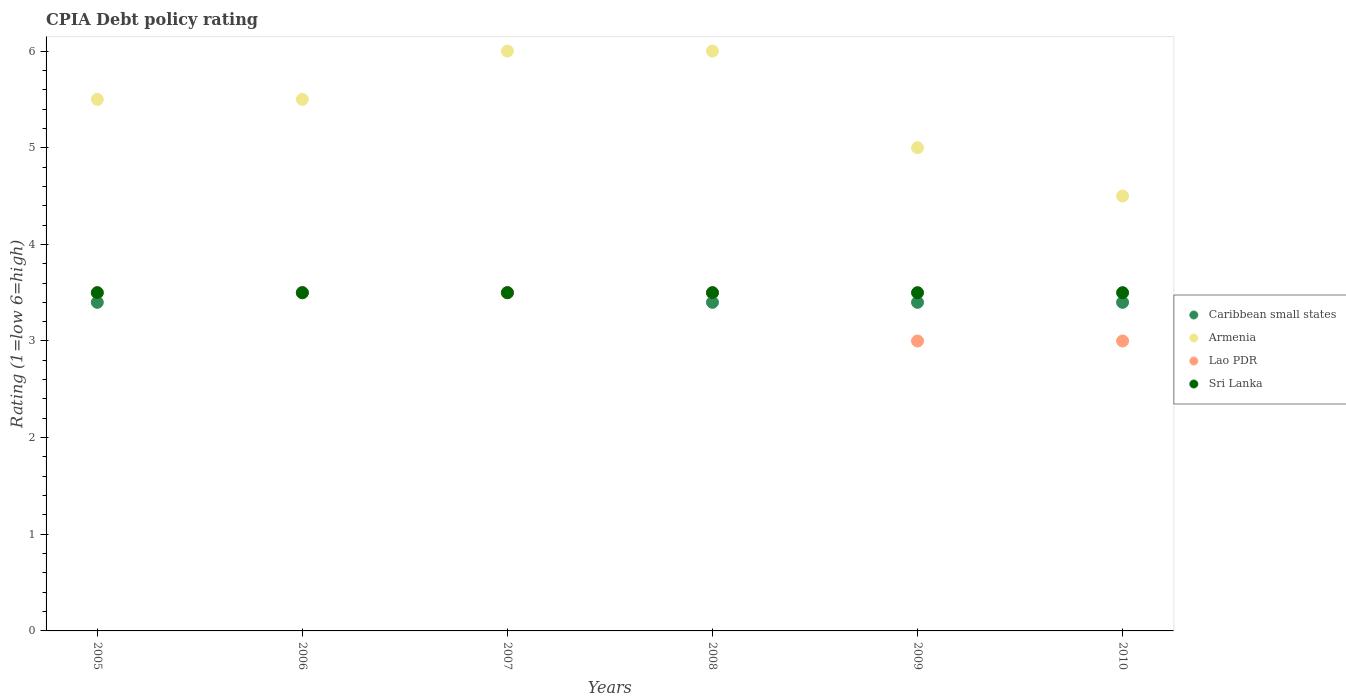Is the number of dotlines equal to the number of legend labels?
Your response must be concise. Yes. Across all years, what is the maximum CPIA rating in Caribbean small states?
Offer a terse response. 3.5. Across all years, what is the minimum CPIA rating in Armenia?
Offer a very short reply. 4.5. What is the difference between the CPIA rating in Sri Lanka in 2009 and that in 2010?
Give a very brief answer. 0. What is the difference between the CPIA rating in Lao PDR in 2010 and the CPIA rating in Armenia in 2007?
Give a very brief answer. -3. What is the average CPIA rating in Lao PDR per year?
Your answer should be very brief. 3.33. In the year 2008, what is the difference between the CPIA rating in Caribbean small states and CPIA rating in Lao PDR?
Make the answer very short. -0.1. In how many years, is the CPIA rating in Caribbean small states greater than 2.6?
Offer a terse response. 6. What is the ratio of the CPIA rating in Caribbean small states in 2007 to that in 2008?
Keep it short and to the point. 1.03. Is it the case that in every year, the sum of the CPIA rating in Armenia and CPIA rating in Lao PDR  is greater than the CPIA rating in Sri Lanka?
Your answer should be very brief. Yes. Does the CPIA rating in Armenia monotonically increase over the years?
Ensure brevity in your answer.  No. Is the CPIA rating in Caribbean small states strictly greater than the CPIA rating in Armenia over the years?
Keep it short and to the point. No. How many dotlines are there?
Keep it short and to the point. 4. Are the values on the major ticks of Y-axis written in scientific E-notation?
Provide a short and direct response. No. Does the graph contain any zero values?
Your answer should be very brief. No. How many legend labels are there?
Keep it short and to the point. 4. What is the title of the graph?
Give a very brief answer. CPIA Debt policy rating. Does "New Caledonia" appear as one of the legend labels in the graph?
Offer a terse response. No. What is the label or title of the X-axis?
Your response must be concise. Years. What is the Rating (1=low 6=high) in Caribbean small states in 2005?
Give a very brief answer. 3.4. What is the Rating (1=low 6=high) in Armenia in 2005?
Offer a terse response. 5.5. What is the Rating (1=low 6=high) of Sri Lanka in 2005?
Offer a very short reply. 3.5. What is the Rating (1=low 6=high) in Lao PDR in 2006?
Provide a short and direct response. 3.5. What is the Rating (1=low 6=high) in Caribbean small states in 2007?
Your response must be concise. 3.5. What is the Rating (1=low 6=high) of Armenia in 2007?
Offer a very short reply. 6. What is the Rating (1=low 6=high) in Lao PDR in 2007?
Make the answer very short. 3.5. What is the Rating (1=low 6=high) in Armenia in 2008?
Make the answer very short. 6. What is the Rating (1=low 6=high) in Sri Lanka in 2008?
Your answer should be compact. 3.5. What is the Rating (1=low 6=high) in Caribbean small states in 2009?
Keep it short and to the point. 3.4. What is the Rating (1=low 6=high) of Armenia in 2009?
Your answer should be compact. 5. What is the Rating (1=low 6=high) of Sri Lanka in 2009?
Provide a short and direct response. 3.5. What is the Rating (1=low 6=high) in Armenia in 2010?
Keep it short and to the point. 4.5. What is the Rating (1=low 6=high) in Lao PDR in 2010?
Ensure brevity in your answer.  3. Across all years, what is the maximum Rating (1=low 6=high) in Sri Lanka?
Offer a very short reply. 3.5. Across all years, what is the minimum Rating (1=low 6=high) in Armenia?
Give a very brief answer. 4.5. What is the total Rating (1=low 6=high) of Caribbean small states in the graph?
Provide a short and direct response. 20.6. What is the total Rating (1=low 6=high) in Armenia in the graph?
Your answer should be very brief. 32.5. What is the difference between the Rating (1=low 6=high) in Lao PDR in 2005 and that in 2006?
Offer a very short reply. 0. What is the difference between the Rating (1=low 6=high) of Sri Lanka in 2005 and that in 2006?
Keep it short and to the point. 0. What is the difference between the Rating (1=low 6=high) of Caribbean small states in 2005 and that in 2007?
Offer a very short reply. -0.1. What is the difference between the Rating (1=low 6=high) of Armenia in 2005 and that in 2007?
Provide a short and direct response. -0.5. What is the difference between the Rating (1=low 6=high) of Lao PDR in 2005 and that in 2007?
Your answer should be very brief. 0. What is the difference between the Rating (1=low 6=high) of Sri Lanka in 2005 and that in 2007?
Provide a succinct answer. 0. What is the difference between the Rating (1=low 6=high) of Armenia in 2005 and that in 2008?
Your answer should be compact. -0.5. What is the difference between the Rating (1=low 6=high) of Lao PDR in 2005 and that in 2008?
Your answer should be very brief. 0. What is the difference between the Rating (1=low 6=high) in Sri Lanka in 2005 and that in 2008?
Ensure brevity in your answer.  0. What is the difference between the Rating (1=low 6=high) in Caribbean small states in 2005 and that in 2009?
Your answer should be compact. 0. What is the difference between the Rating (1=low 6=high) in Lao PDR in 2005 and that in 2009?
Make the answer very short. 0.5. What is the difference between the Rating (1=low 6=high) in Sri Lanka in 2005 and that in 2009?
Provide a short and direct response. 0. What is the difference between the Rating (1=low 6=high) of Armenia in 2005 and that in 2010?
Provide a short and direct response. 1. What is the difference between the Rating (1=low 6=high) of Lao PDR in 2005 and that in 2010?
Provide a short and direct response. 0.5. What is the difference between the Rating (1=low 6=high) in Caribbean small states in 2006 and that in 2007?
Ensure brevity in your answer.  0. What is the difference between the Rating (1=low 6=high) in Armenia in 2006 and that in 2007?
Ensure brevity in your answer.  -0.5. What is the difference between the Rating (1=low 6=high) in Lao PDR in 2006 and that in 2007?
Ensure brevity in your answer.  0. What is the difference between the Rating (1=low 6=high) in Caribbean small states in 2006 and that in 2008?
Keep it short and to the point. 0.1. What is the difference between the Rating (1=low 6=high) of Caribbean small states in 2006 and that in 2009?
Offer a terse response. 0.1. What is the difference between the Rating (1=low 6=high) in Caribbean small states in 2006 and that in 2010?
Ensure brevity in your answer.  0.1. What is the difference between the Rating (1=low 6=high) in Lao PDR in 2006 and that in 2010?
Keep it short and to the point. 0.5. What is the difference between the Rating (1=low 6=high) of Sri Lanka in 2006 and that in 2010?
Provide a succinct answer. 0. What is the difference between the Rating (1=low 6=high) in Armenia in 2007 and that in 2008?
Provide a succinct answer. 0. What is the difference between the Rating (1=low 6=high) of Armenia in 2007 and that in 2009?
Keep it short and to the point. 1. What is the difference between the Rating (1=low 6=high) of Armenia in 2007 and that in 2010?
Offer a very short reply. 1.5. What is the difference between the Rating (1=low 6=high) in Lao PDR in 2007 and that in 2010?
Provide a succinct answer. 0.5. What is the difference between the Rating (1=low 6=high) of Sri Lanka in 2008 and that in 2009?
Provide a succinct answer. 0. What is the difference between the Rating (1=low 6=high) of Sri Lanka in 2008 and that in 2010?
Offer a terse response. 0. What is the difference between the Rating (1=low 6=high) in Caribbean small states in 2009 and that in 2010?
Offer a very short reply. 0. What is the difference between the Rating (1=low 6=high) in Caribbean small states in 2005 and the Rating (1=low 6=high) in Lao PDR in 2006?
Ensure brevity in your answer.  -0.1. What is the difference between the Rating (1=low 6=high) in Armenia in 2005 and the Rating (1=low 6=high) in Lao PDR in 2006?
Provide a succinct answer. 2. What is the difference between the Rating (1=low 6=high) of Lao PDR in 2005 and the Rating (1=low 6=high) of Sri Lanka in 2006?
Make the answer very short. 0. What is the difference between the Rating (1=low 6=high) in Caribbean small states in 2005 and the Rating (1=low 6=high) in Lao PDR in 2007?
Give a very brief answer. -0.1. What is the difference between the Rating (1=low 6=high) in Caribbean small states in 2005 and the Rating (1=low 6=high) in Sri Lanka in 2007?
Your answer should be compact. -0.1. What is the difference between the Rating (1=low 6=high) in Lao PDR in 2005 and the Rating (1=low 6=high) in Sri Lanka in 2007?
Keep it short and to the point. 0. What is the difference between the Rating (1=low 6=high) in Caribbean small states in 2005 and the Rating (1=low 6=high) in Lao PDR in 2008?
Offer a terse response. -0.1. What is the difference between the Rating (1=low 6=high) of Caribbean small states in 2005 and the Rating (1=low 6=high) of Sri Lanka in 2008?
Offer a very short reply. -0.1. What is the difference between the Rating (1=low 6=high) in Lao PDR in 2005 and the Rating (1=low 6=high) in Sri Lanka in 2008?
Offer a very short reply. 0. What is the difference between the Rating (1=low 6=high) of Caribbean small states in 2005 and the Rating (1=low 6=high) of Armenia in 2009?
Make the answer very short. -1.6. What is the difference between the Rating (1=low 6=high) in Armenia in 2005 and the Rating (1=low 6=high) in Sri Lanka in 2009?
Offer a terse response. 2. What is the difference between the Rating (1=low 6=high) in Caribbean small states in 2005 and the Rating (1=low 6=high) in Armenia in 2010?
Offer a terse response. -1.1. What is the difference between the Rating (1=low 6=high) in Armenia in 2005 and the Rating (1=low 6=high) in Lao PDR in 2010?
Your answer should be compact. 2.5. What is the difference between the Rating (1=low 6=high) of Armenia in 2005 and the Rating (1=low 6=high) of Sri Lanka in 2010?
Your answer should be very brief. 2. What is the difference between the Rating (1=low 6=high) in Caribbean small states in 2006 and the Rating (1=low 6=high) in Armenia in 2007?
Keep it short and to the point. -2.5. What is the difference between the Rating (1=low 6=high) in Armenia in 2006 and the Rating (1=low 6=high) in Sri Lanka in 2007?
Your response must be concise. 2. What is the difference between the Rating (1=low 6=high) in Caribbean small states in 2006 and the Rating (1=low 6=high) in Armenia in 2008?
Provide a succinct answer. -2.5. What is the difference between the Rating (1=low 6=high) of Caribbean small states in 2006 and the Rating (1=low 6=high) of Sri Lanka in 2008?
Ensure brevity in your answer.  0. What is the difference between the Rating (1=low 6=high) in Armenia in 2006 and the Rating (1=low 6=high) in Lao PDR in 2008?
Ensure brevity in your answer.  2. What is the difference between the Rating (1=low 6=high) of Armenia in 2006 and the Rating (1=low 6=high) of Sri Lanka in 2008?
Keep it short and to the point. 2. What is the difference between the Rating (1=low 6=high) in Caribbean small states in 2006 and the Rating (1=low 6=high) in Armenia in 2009?
Your response must be concise. -1.5. What is the difference between the Rating (1=low 6=high) in Armenia in 2006 and the Rating (1=low 6=high) in Sri Lanka in 2009?
Offer a very short reply. 2. What is the difference between the Rating (1=low 6=high) of Lao PDR in 2006 and the Rating (1=low 6=high) of Sri Lanka in 2009?
Your response must be concise. 0. What is the difference between the Rating (1=low 6=high) in Caribbean small states in 2006 and the Rating (1=low 6=high) in Armenia in 2010?
Keep it short and to the point. -1. What is the difference between the Rating (1=low 6=high) of Armenia in 2006 and the Rating (1=low 6=high) of Lao PDR in 2010?
Give a very brief answer. 2.5. What is the difference between the Rating (1=low 6=high) in Lao PDR in 2006 and the Rating (1=low 6=high) in Sri Lanka in 2010?
Offer a very short reply. 0. What is the difference between the Rating (1=low 6=high) of Caribbean small states in 2007 and the Rating (1=low 6=high) of Armenia in 2008?
Ensure brevity in your answer.  -2.5. What is the difference between the Rating (1=low 6=high) in Caribbean small states in 2007 and the Rating (1=low 6=high) in Lao PDR in 2008?
Provide a short and direct response. 0. What is the difference between the Rating (1=low 6=high) of Armenia in 2007 and the Rating (1=low 6=high) of Lao PDR in 2008?
Offer a very short reply. 2.5. What is the difference between the Rating (1=low 6=high) in Armenia in 2007 and the Rating (1=low 6=high) in Sri Lanka in 2008?
Your answer should be compact. 2.5. What is the difference between the Rating (1=low 6=high) in Lao PDR in 2007 and the Rating (1=low 6=high) in Sri Lanka in 2008?
Your answer should be very brief. 0. What is the difference between the Rating (1=low 6=high) in Armenia in 2007 and the Rating (1=low 6=high) in Sri Lanka in 2009?
Provide a succinct answer. 2.5. What is the difference between the Rating (1=low 6=high) in Lao PDR in 2007 and the Rating (1=low 6=high) in Sri Lanka in 2009?
Give a very brief answer. 0. What is the difference between the Rating (1=low 6=high) in Caribbean small states in 2007 and the Rating (1=low 6=high) in Armenia in 2010?
Offer a terse response. -1. What is the difference between the Rating (1=low 6=high) of Caribbean small states in 2007 and the Rating (1=low 6=high) of Lao PDR in 2010?
Ensure brevity in your answer.  0.5. What is the difference between the Rating (1=low 6=high) in Lao PDR in 2007 and the Rating (1=low 6=high) in Sri Lanka in 2010?
Your answer should be very brief. 0. What is the difference between the Rating (1=low 6=high) of Caribbean small states in 2008 and the Rating (1=low 6=high) of Lao PDR in 2009?
Your answer should be very brief. 0.4. What is the difference between the Rating (1=low 6=high) of Caribbean small states in 2008 and the Rating (1=low 6=high) of Sri Lanka in 2009?
Offer a terse response. -0.1. What is the difference between the Rating (1=low 6=high) in Armenia in 2008 and the Rating (1=low 6=high) in Lao PDR in 2009?
Provide a succinct answer. 3. What is the difference between the Rating (1=low 6=high) in Caribbean small states in 2008 and the Rating (1=low 6=high) in Armenia in 2010?
Provide a succinct answer. -1.1. What is the difference between the Rating (1=low 6=high) of Caribbean small states in 2008 and the Rating (1=low 6=high) of Lao PDR in 2010?
Offer a terse response. 0.4. What is the difference between the Rating (1=low 6=high) of Caribbean small states in 2008 and the Rating (1=low 6=high) of Sri Lanka in 2010?
Provide a short and direct response. -0.1. What is the difference between the Rating (1=low 6=high) of Armenia in 2008 and the Rating (1=low 6=high) of Sri Lanka in 2010?
Your answer should be very brief. 2.5. What is the difference between the Rating (1=low 6=high) in Lao PDR in 2008 and the Rating (1=low 6=high) in Sri Lanka in 2010?
Offer a terse response. 0. What is the difference between the Rating (1=low 6=high) in Caribbean small states in 2009 and the Rating (1=low 6=high) in Lao PDR in 2010?
Offer a terse response. 0.4. What is the difference between the Rating (1=low 6=high) of Armenia in 2009 and the Rating (1=low 6=high) of Sri Lanka in 2010?
Ensure brevity in your answer.  1.5. What is the average Rating (1=low 6=high) in Caribbean small states per year?
Your answer should be compact. 3.43. What is the average Rating (1=low 6=high) in Armenia per year?
Keep it short and to the point. 5.42. What is the average Rating (1=low 6=high) in Lao PDR per year?
Give a very brief answer. 3.33. In the year 2005, what is the difference between the Rating (1=low 6=high) of Armenia and Rating (1=low 6=high) of Sri Lanka?
Offer a very short reply. 2. In the year 2006, what is the difference between the Rating (1=low 6=high) of Caribbean small states and Rating (1=low 6=high) of Armenia?
Make the answer very short. -2. In the year 2006, what is the difference between the Rating (1=low 6=high) of Caribbean small states and Rating (1=low 6=high) of Lao PDR?
Give a very brief answer. 0. In the year 2006, what is the difference between the Rating (1=low 6=high) in Caribbean small states and Rating (1=low 6=high) in Sri Lanka?
Your answer should be compact. 0. In the year 2006, what is the difference between the Rating (1=low 6=high) of Armenia and Rating (1=low 6=high) of Lao PDR?
Give a very brief answer. 2. In the year 2006, what is the difference between the Rating (1=low 6=high) in Armenia and Rating (1=low 6=high) in Sri Lanka?
Provide a succinct answer. 2. In the year 2007, what is the difference between the Rating (1=low 6=high) of Caribbean small states and Rating (1=low 6=high) of Sri Lanka?
Provide a short and direct response. 0. In the year 2007, what is the difference between the Rating (1=low 6=high) in Armenia and Rating (1=low 6=high) in Lao PDR?
Your response must be concise. 2.5. In the year 2007, what is the difference between the Rating (1=low 6=high) of Armenia and Rating (1=low 6=high) of Sri Lanka?
Offer a terse response. 2.5. In the year 2007, what is the difference between the Rating (1=low 6=high) of Lao PDR and Rating (1=low 6=high) of Sri Lanka?
Offer a very short reply. 0. In the year 2008, what is the difference between the Rating (1=low 6=high) of Caribbean small states and Rating (1=low 6=high) of Armenia?
Your response must be concise. -2.6. In the year 2008, what is the difference between the Rating (1=low 6=high) in Caribbean small states and Rating (1=low 6=high) in Lao PDR?
Offer a very short reply. -0.1. In the year 2008, what is the difference between the Rating (1=low 6=high) in Armenia and Rating (1=low 6=high) in Sri Lanka?
Give a very brief answer. 2.5. In the year 2009, what is the difference between the Rating (1=low 6=high) in Caribbean small states and Rating (1=low 6=high) in Armenia?
Keep it short and to the point. -1.6. In the year 2009, what is the difference between the Rating (1=low 6=high) in Caribbean small states and Rating (1=low 6=high) in Lao PDR?
Your answer should be compact. 0.4. In the year 2009, what is the difference between the Rating (1=low 6=high) in Caribbean small states and Rating (1=low 6=high) in Sri Lanka?
Offer a very short reply. -0.1. In the year 2009, what is the difference between the Rating (1=low 6=high) of Armenia and Rating (1=low 6=high) of Lao PDR?
Give a very brief answer. 2. In the year 2009, what is the difference between the Rating (1=low 6=high) of Lao PDR and Rating (1=low 6=high) of Sri Lanka?
Ensure brevity in your answer.  -0.5. In the year 2010, what is the difference between the Rating (1=low 6=high) of Caribbean small states and Rating (1=low 6=high) of Armenia?
Provide a short and direct response. -1.1. In the year 2010, what is the difference between the Rating (1=low 6=high) in Armenia and Rating (1=low 6=high) in Lao PDR?
Provide a short and direct response. 1.5. In the year 2010, what is the difference between the Rating (1=low 6=high) in Armenia and Rating (1=low 6=high) in Sri Lanka?
Keep it short and to the point. 1. In the year 2010, what is the difference between the Rating (1=low 6=high) in Lao PDR and Rating (1=low 6=high) in Sri Lanka?
Give a very brief answer. -0.5. What is the ratio of the Rating (1=low 6=high) of Caribbean small states in 2005 to that in 2006?
Keep it short and to the point. 0.97. What is the ratio of the Rating (1=low 6=high) in Lao PDR in 2005 to that in 2006?
Keep it short and to the point. 1. What is the ratio of the Rating (1=low 6=high) of Sri Lanka in 2005 to that in 2006?
Offer a very short reply. 1. What is the ratio of the Rating (1=low 6=high) in Caribbean small states in 2005 to that in 2007?
Your answer should be very brief. 0.97. What is the ratio of the Rating (1=low 6=high) of Armenia in 2005 to that in 2007?
Make the answer very short. 0.92. What is the ratio of the Rating (1=low 6=high) in Lao PDR in 2005 to that in 2007?
Your answer should be very brief. 1. What is the ratio of the Rating (1=low 6=high) of Sri Lanka in 2005 to that in 2007?
Your answer should be very brief. 1. What is the ratio of the Rating (1=low 6=high) of Caribbean small states in 2005 to that in 2008?
Offer a very short reply. 1. What is the ratio of the Rating (1=low 6=high) of Armenia in 2005 to that in 2008?
Your answer should be very brief. 0.92. What is the ratio of the Rating (1=low 6=high) in Sri Lanka in 2005 to that in 2008?
Offer a terse response. 1. What is the ratio of the Rating (1=low 6=high) in Caribbean small states in 2005 to that in 2009?
Your answer should be very brief. 1. What is the ratio of the Rating (1=low 6=high) of Lao PDR in 2005 to that in 2009?
Offer a terse response. 1.17. What is the ratio of the Rating (1=low 6=high) of Sri Lanka in 2005 to that in 2009?
Your answer should be compact. 1. What is the ratio of the Rating (1=low 6=high) in Caribbean small states in 2005 to that in 2010?
Make the answer very short. 1. What is the ratio of the Rating (1=low 6=high) in Armenia in 2005 to that in 2010?
Keep it short and to the point. 1.22. What is the ratio of the Rating (1=low 6=high) of Sri Lanka in 2005 to that in 2010?
Provide a succinct answer. 1. What is the ratio of the Rating (1=low 6=high) in Caribbean small states in 2006 to that in 2007?
Your answer should be very brief. 1. What is the ratio of the Rating (1=low 6=high) in Sri Lanka in 2006 to that in 2007?
Offer a terse response. 1. What is the ratio of the Rating (1=low 6=high) of Caribbean small states in 2006 to that in 2008?
Provide a succinct answer. 1.03. What is the ratio of the Rating (1=low 6=high) in Armenia in 2006 to that in 2008?
Your response must be concise. 0.92. What is the ratio of the Rating (1=low 6=high) of Lao PDR in 2006 to that in 2008?
Keep it short and to the point. 1. What is the ratio of the Rating (1=low 6=high) in Sri Lanka in 2006 to that in 2008?
Offer a terse response. 1. What is the ratio of the Rating (1=low 6=high) in Caribbean small states in 2006 to that in 2009?
Give a very brief answer. 1.03. What is the ratio of the Rating (1=low 6=high) of Armenia in 2006 to that in 2009?
Ensure brevity in your answer.  1.1. What is the ratio of the Rating (1=low 6=high) in Lao PDR in 2006 to that in 2009?
Your answer should be compact. 1.17. What is the ratio of the Rating (1=low 6=high) in Sri Lanka in 2006 to that in 2009?
Your answer should be very brief. 1. What is the ratio of the Rating (1=low 6=high) of Caribbean small states in 2006 to that in 2010?
Provide a succinct answer. 1.03. What is the ratio of the Rating (1=low 6=high) in Armenia in 2006 to that in 2010?
Your answer should be very brief. 1.22. What is the ratio of the Rating (1=low 6=high) in Lao PDR in 2006 to that in 2010?
Give a very brief answer. 1.17. What is the ratio of the Rating (1=low 6=high) of Sri Lanka in 2006 to that in 2010?
Make the answer very short. 1. What is the ratio of the Rating (1=low 6=high) in Caribbean small states in 2007 to that in 2008?
Make the answer very short. 1.03. What is the ratio of the Rating (1=low 6=high) in Lao PDR in 2007 to that in 2008?
Offer a terse response. 1. What is the ratio of the Rating (1=low 6=high) in Caribbean small states in 2007 to that in 2009?
Your answer should be compact. 1.03. What is the ratio of the Rating (1=low 6=high) in Lao PDR in 2007 to that in 2009?
Offer a terse response. 1.17. What is the ratio of the Rating (1=low 6=high) in Caribbean small states in 2007 to that in 2010?
Your answer should be compact. 1.03. What is the ratio of the Rating (1=low 6=high) of Armenia in 2007 to that in 2010?
Your response must be concise. 1.33. What is the ratio of the Rating (1=low 6=high) in Sri Lanka in 2007 to that in 2010?
Give a very brief answer. 1. What is the ratio of the Rating (1=low 6=high) of Caribbean small states in 2008 to that in 2010?
Offer a terse response. 1. What is the ratio of the Rating (1=low 6=high) in Caribbean small states in 2009 to that in 2010?
Provide a short and direct response. 1. What is the ratio of the Rating (1=low 6=high) of Lao PDR in 2009 to that in 2010?
Offer a terse response. 1. What is the difference between the highest and the second highest Rating (1=low 6=high) in Lao PDR?
Give a very brief answer. 0. What is the difference between the highest and the lowest Rating (1=low 6=high) of Armenia?
Your answer should be compact. 1.5. What is the difference between the highest and the lowest Rating (1=low 6=high) of Lao PDR?
Make the answer very short. 0.5. What is the difference between the highest and the lowest Rating (1=low 6=high) in Sri Lanka?
Provide a succinct answer. 0. 